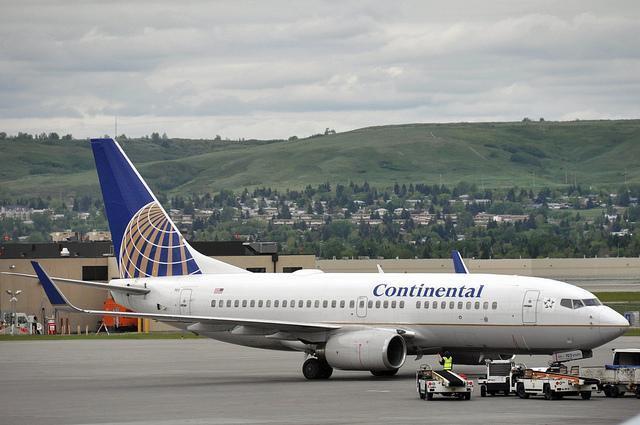How many trucks are visible?
Give a very brief answer. 2. 